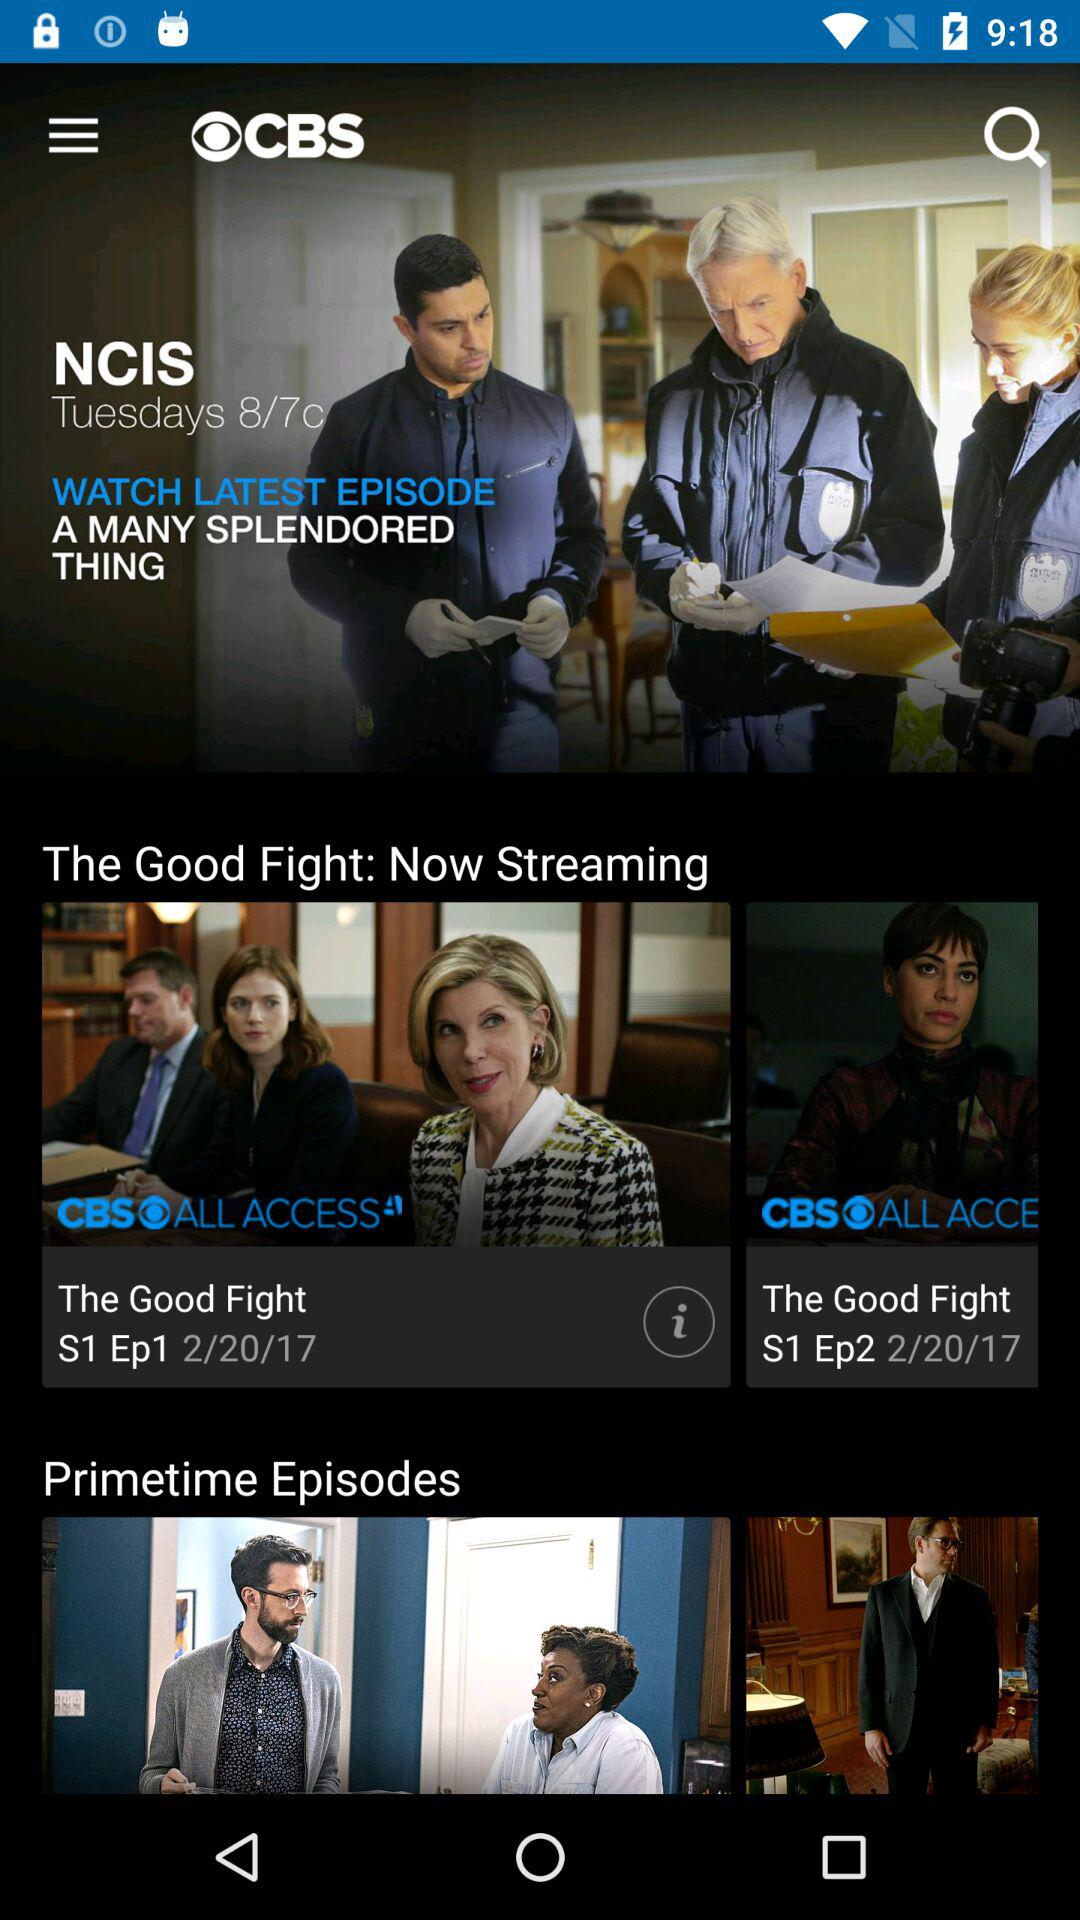What is the day on the selected date? The day on the selected date is Wednesday. 